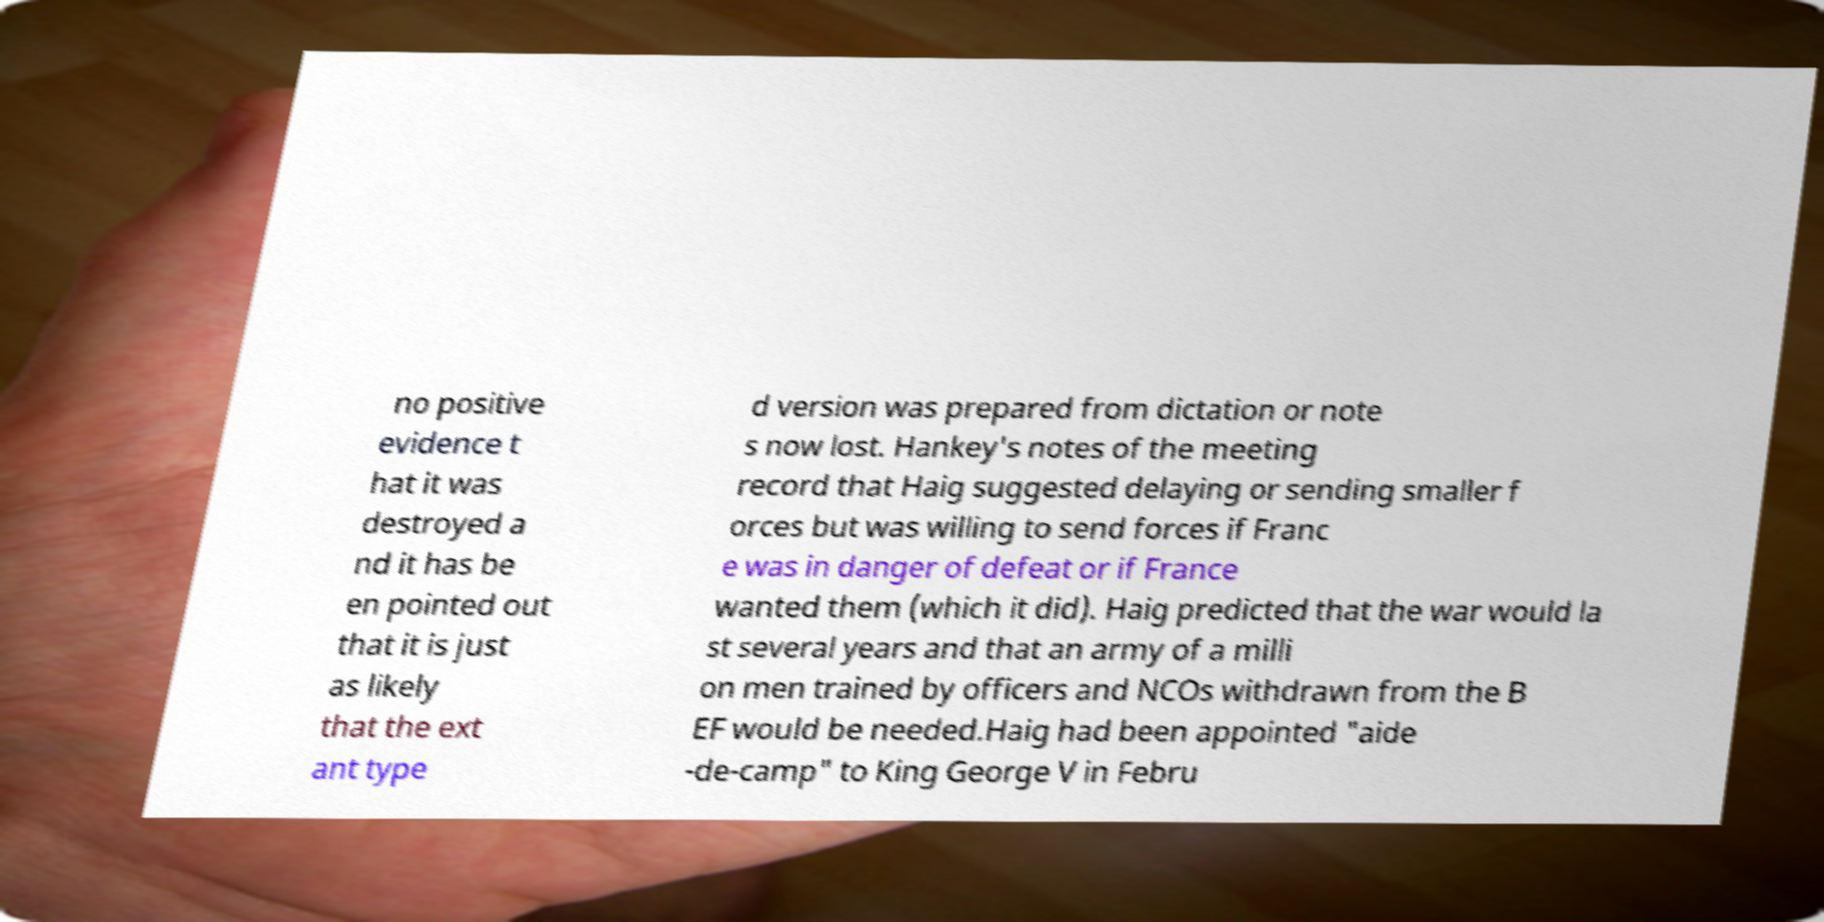Please read and relay the text visible in this image. What does it say? no positive evidence t hat it was destroyed a nd it has be en pointed out that it is just as likely that the ext ant type d version was prepared from dictation or note s now lost. Hankey's notes of the meeting record that Haig suggested delaying or sending smaller f orces but was willing to send forces if Franc e was in danger of defeat or if France wanted them (which it did). Haig predicted that the war would la st several years and that an army of a milli on men trained by officers and NCOs withdrawn from the B EF would be needed.Haig had been appointed "aide -de-camp" to King George V in Febru 